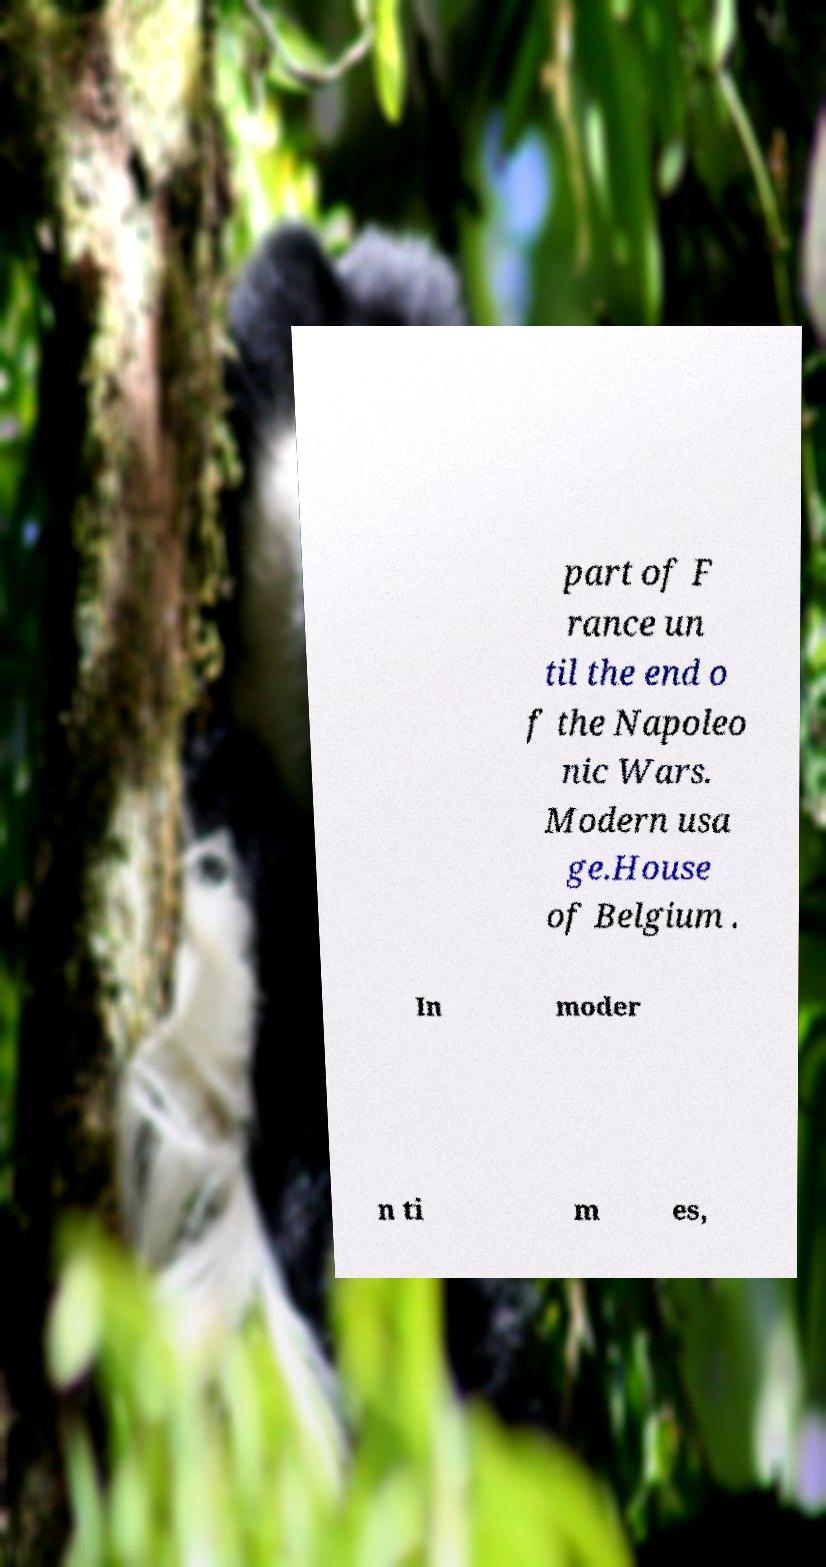Please identify and transcribe the text found in this image. part of F rance un til the end o f the Napoleo nic Wars. Modern usa ge.House of Belgium . In moder n ti m es, 